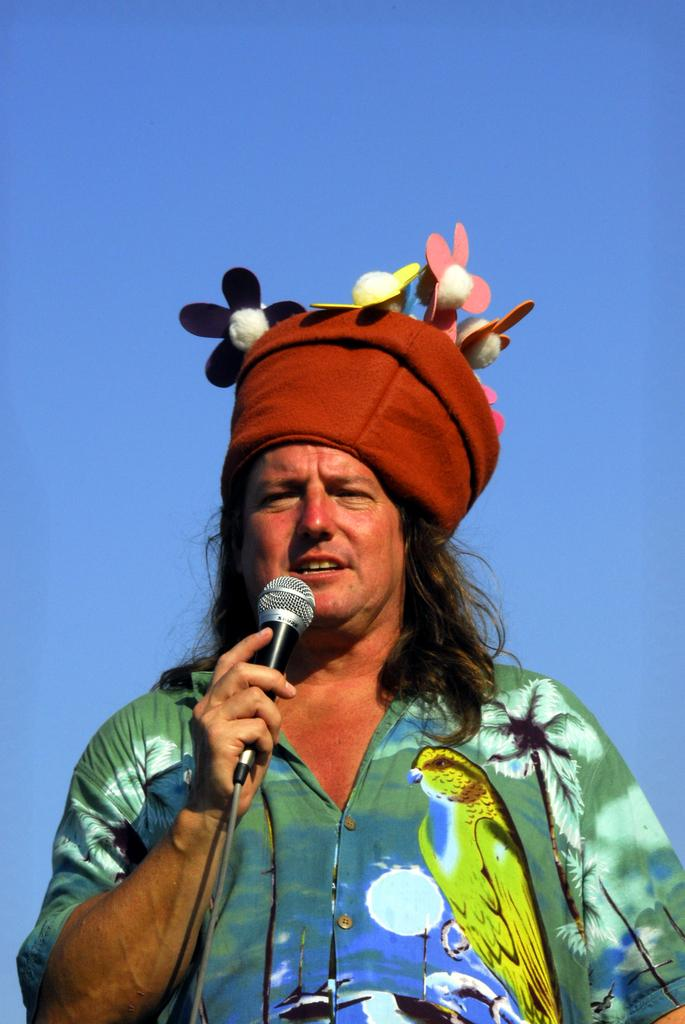Who is the main subject in the image? There is a man in the image. What is the man holding in the image? The man is holding a microphone. Can you describe the man's appearance? The man has long hair and is wearing a red color cap. What type of vacation is the man planning to take in the image? There is no information about a vacation in the image. 